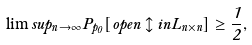Convert formula to latex. <formula><loc_0><loc_0><loc_500><loc_500>\lim s u p _ { n \rightarrow \infty } P _ { p _ { 0 } } [ o p e n \updownarrow i n L _ { n \times n } ] \geq \frac { 1 } { 2 } ,</formula> 